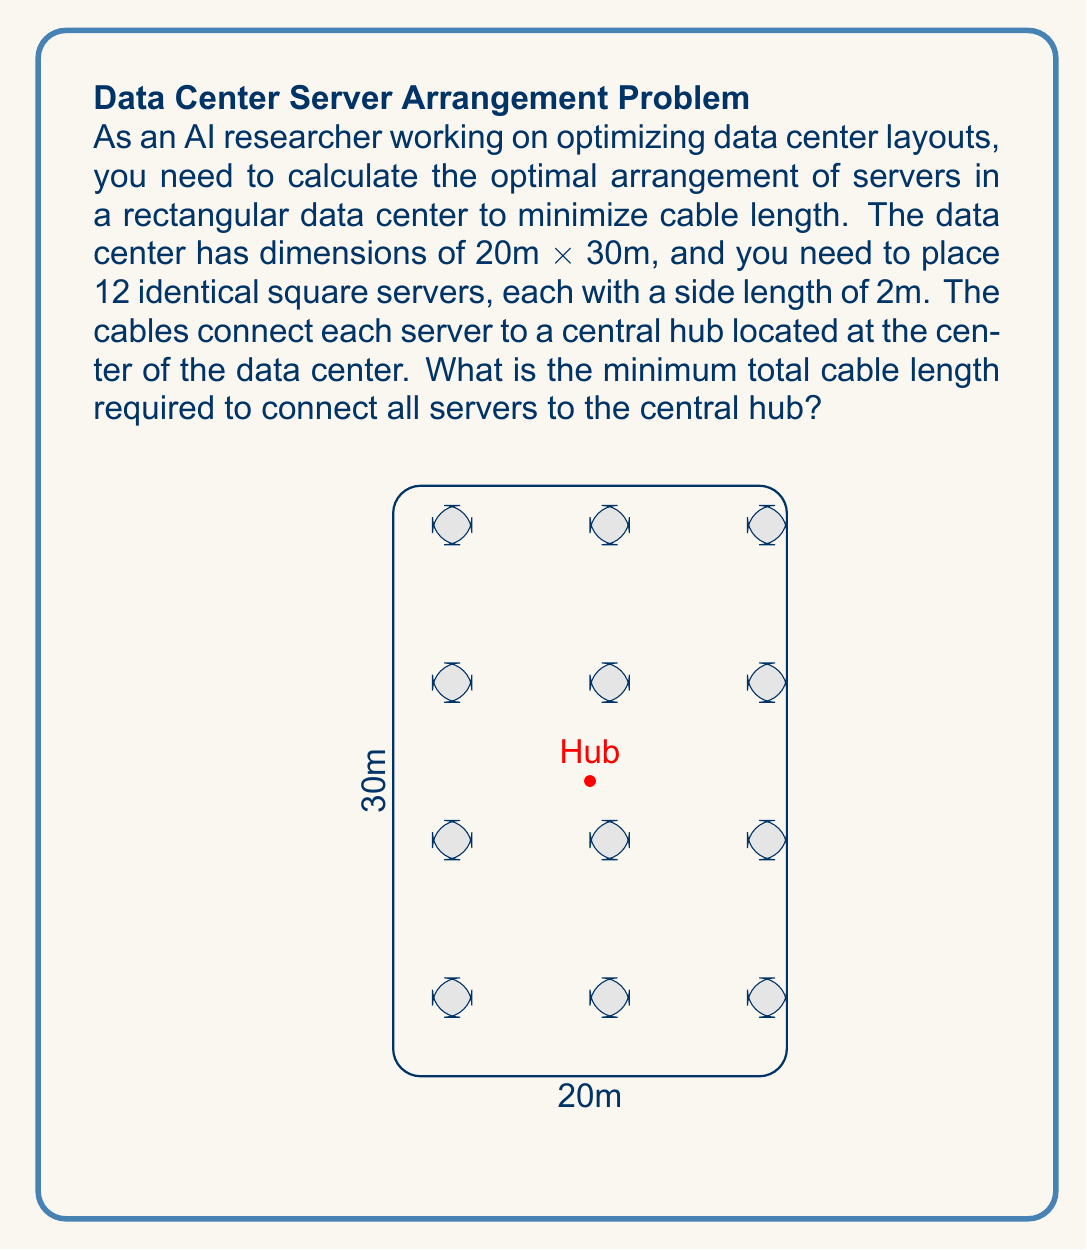Solve this math problem. To solve this problem, we'll follow these steps:

1) First, we need to determine the optimal arrangement of servers. The most efficient layout would be to place the servers in a grid-like pattern, evenly distributed around the central hub.

2) Given the data center dimensions (20m x 30m) and the number of servers (12), we can arrange them in a 3x4 grid.

3) To minimize cable length, we need to position the servers symmetrically around the central hub. The center of each server should be placed at:

   $x_i = 3 + 8i$ (for $i = 0, 1, 2$)
   $y_j = 5 + 8j$ (for $j = 0, 1, 2, 3$)

4) The central hub is located at the center of the data center: (10, 15)

5) For each server, we need to calculate its distance from the central hub using the distance formula:

   $$d = \sqrt{(x_2 - x_1)^2 + (y_2 - y_1)^2}$$

6) Let's calculate the distance for each server:

   Server 1: $\sqrt{(3 - 10)^2 + (5 - 15)^2} = \sqrt{49 + 100} = \sqrt{149}$
   Server 2: $\sqrt{(3 - 10)^2 + (13 - 15)^2} = \sqrt{49 + 4} = \sqrt{53}$
   Server 3: $\sqrt{(3 - 10)^2 + (21 - 15)^2} = \sqrt{49 + 36} = \sqrt{85}$
   Server 4: $\sqrt{(3 - 10)^2 + (29 - 15)^2} = \sqrt{49 + 196} = \sqrt{245}$
   
   Server 5: $\sqrt{(11 - 10)^2 + (5 - 15)^2} = \sqrt{1 + 100} = \sqrt{101}$
   Server 6: $\sqrt{(11 - 10)^2 + (13 - 15)^2} = \sqrt{1 + 4} = \sqrt{5}$
   Server 7: $\sqrt{(11 - 10)^2 + (21 - 15)^2} = \sqrt{1 + 36} = \sqrt{37}$
   Server 8: $\sqrt{(11 - 10)^2 + (29 - 15)^2} = \sqrt{1 + 196} = \sqrt{197}$
   
   Server 9: $\sqrt{(19 - 10)^2 + (5 - 15)^2} = \sqrt{81 + 100} = \sqrt{181}$
   Server 10: $\sqrt{(19 - 10)^2 + (13 - 15)^2} = \sqrt{81 + 4} = \sqrt{85}$
   Server 11: $\sqrt{(19 - 10)^2 + (21 - 15)^2} = \sqrt{81 + 36} = \sqrt{117}$
   Server 12: $\sqrt{(19 - 10)^2 + (29 - 15)^2} = \sqrt{81 + 196} = \sqrt{277}$

7) The total cable length is the sum of all these distances:

   $$\text{Total Length} = \sum_{i=1}^{12} d_i$$

8) Summing up all the square roots:

   $$\text{Total Length} = \sqrt{149} + \sqrt{53} + \sqrt{85} + \sqrt{245} + \sqrt{101} + \sqrt{5} + \sqrt{37} + \sqrt{197} + \sqrt{181} + \sqrt{85} + \sqrt{117} + \sqrt{277}$$

9) This sum cannot be simplified further without approximation.
Answer: $\sqrt{149} + \sqrt{53} + \sqrt{85} + \sqrt{245} + \sqrt{101} + \sqrt{5} + \sqrt{37} + \sqrt{197} + \sqrt{181} + \sqrt{85} + \sqrt{117} + \sqrt{277}$ meters 